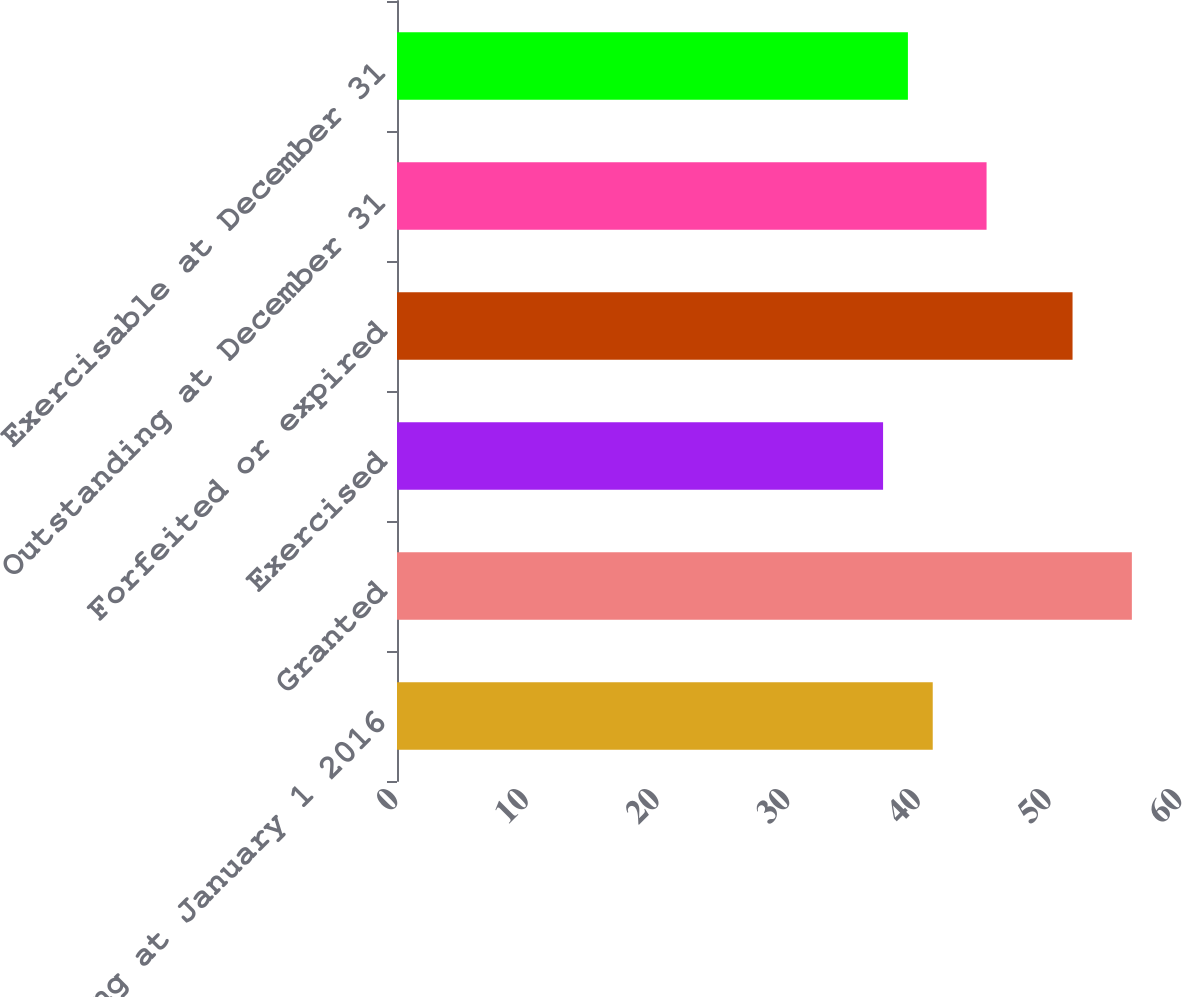<chart> <loc_0><loc_0><loc_500><loc_500><bar_chart><fcel>Outstanding at January 1 2016<fcel>Granted<fcel>Exercised<fcel>Forfeited or expired<fcel>Outstanding at December 31<fcel>Exercisable at December 31<nl><fcel>41<fcel>56.24<fcel>37.2<fcel>51.7<fcel>45.12<fcel>39.1<nl></chart> 